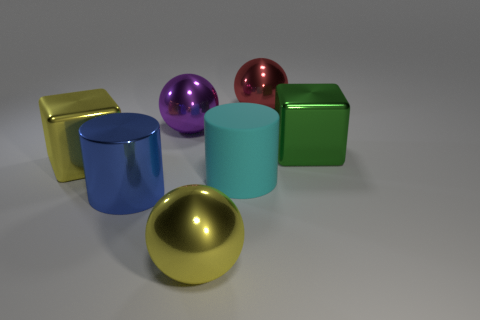Add 2 tiny green cubes. How many objects exist? 9 Subtract all cubes. How many objects are left? 5 Subtract all large balls. Subtract all large green blocks. How many objects are left? 3 Add 5 green cubes. How many green cubes are left? 6 Add 1 green shiny blocks. How many green shiny blocks exist? 2 Subtract 0 cyan spheres. How many objects are left? 7 